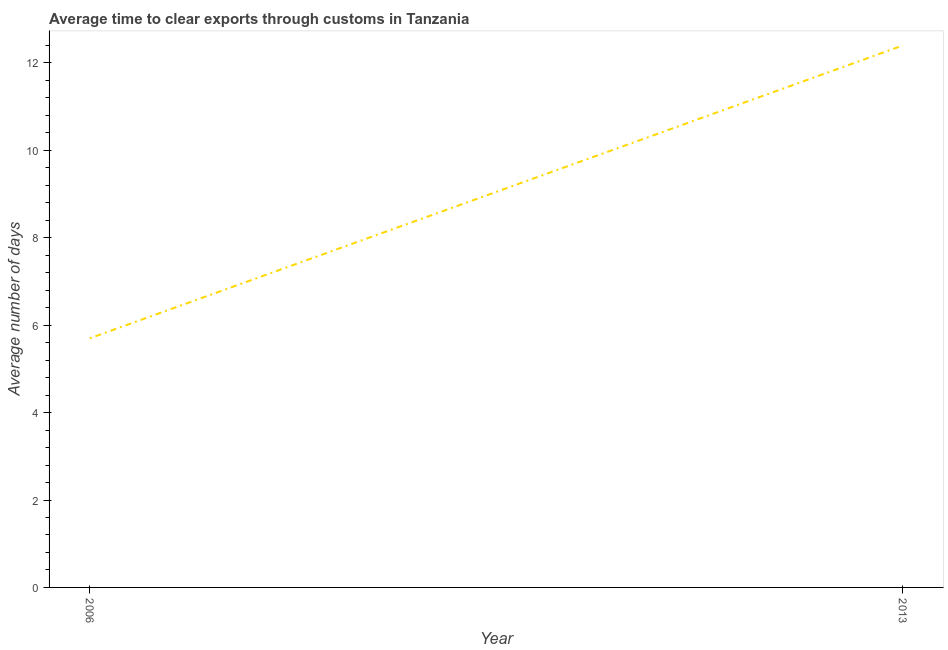What is the time to clear exports through customs in 2006?
Give a very brief answer. 5.7. In which year was the time to clear exports through customs minimum?
Offer a terse response. 2006. What is the average time to clear exports through customs per year?
Give a very brief answer. 9.05. What is the median time to clear exports through customs?
Your answer should be compact. 9.05. What is the ratio of the time to clear exports through customs in 2006 to that in 2013?
Offer a terse response. 0.46. In how many years, is the time to clear exports through customs greater than the average time to clear exports through customs taken over all years?
Offer a very short reply. 1. How many lines are there?
Provide a short and direct response. 1. What is the difference between two consecutive major ticks on the Y-axis?
Ensure brevity in your answer.  2. Are the values on the major ticks of Y-axis written in scientific E-notation?
Your answer should be very brief. No. What is the title of the graph?
Your answer should be very brief. Average time to clear exports through customs in Tanzania. What is the label or title of the X-axis?
Provide a succinct answer. Year. What is the label or title of the Y-axis?
Your answer should be very brief. Average number of days. What is the Average number of days of 2006?
Your answer should be compact. 5.7. What is the Average number of days of 2013?
Your answer should be very brief. 12.4. What is the ratio of the Average number of days in 2006 to that in 2013?
Give a very brief answer. 0.46. 